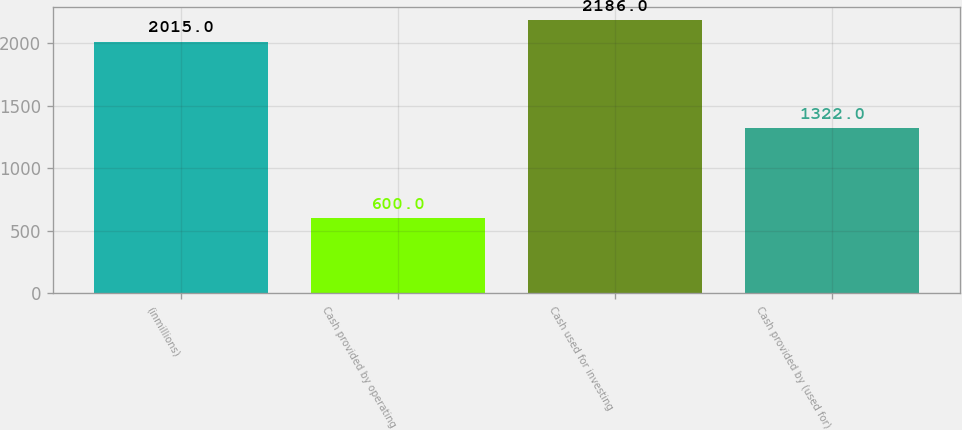Convert chart to OTSL. <chart><loc_0><loc_0><loc_500><loc_500><bar_chart><fcel>(inmillions)<fcel>Cash provided by operating<fcel>Cash used for investing<fcel>Cash provided by (used for)<nl><fcel>2015<fcel>600<fcel>2186<fcel>1322<nl></chart> 